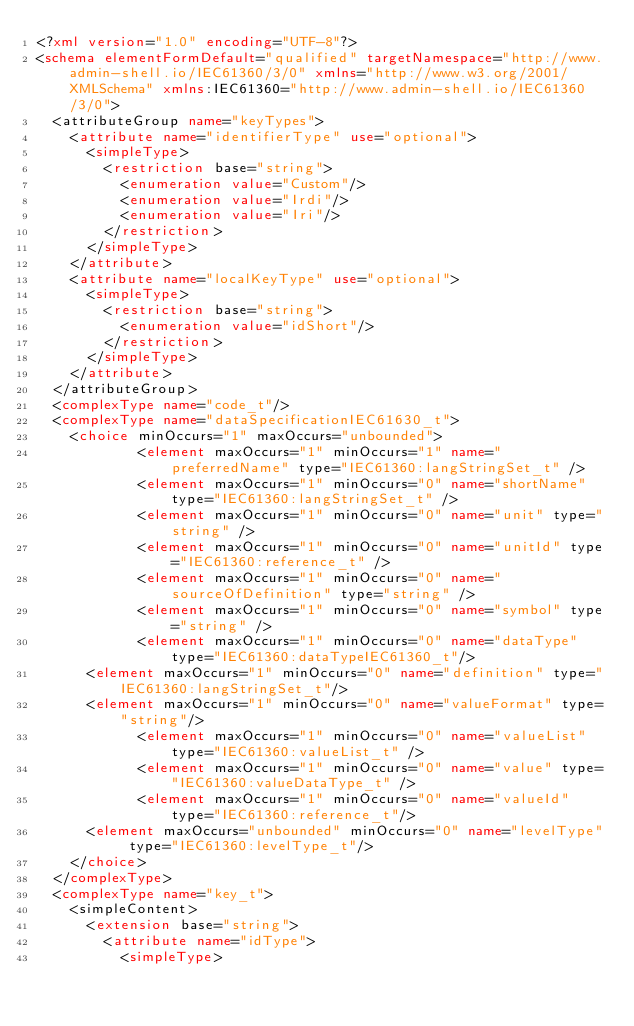Convert code to text. <code><loc_0><loc_0><loc_500><loc_500><_XML_><?xml version="1.0" encoding="UTF-8"?>
<schema elementFormDefault="qualified" targetNamespace="http://www.admin-shell.io/IEC61360/3/0" xmlns="http://www.w3.org/2001/XMLSchema" xmlns:IEC61360="http://www.admin-shell.io/IEC61360/3/0">
	<attributeGroup name="keyTypes">
		<attribute name="identifierType" use="optional">
			<simpleType>
				<restriction base="string">
					<enumeration value="Custom"/>
					<enumeration value="Irdi"/>
					<enumeration value="Iri"/>
				</restriction>
			</simpleType>
		</attribute>
		<attribute name="localKeyType" use="optional">
			<simpleType>
				<restriction base="string">
					<enumeration value="idShort"/>
				</restriction>
			</simpleType>
		</attribute>
	</attributeGroup>
	<complexType name="code_t"/>
	<complexType name="dataSpecificationIEC61630_t">
		<choice minOccurs="1" maxOccurs="unbounded">
            <element maxOccurs="1" minOccurs="1" name="preferredName" type="IEC61360:langStringSet_t" />
            <element maxOccurs="1" minOccurs="0" name="shortName" type="IEC61360:langStringSet_t" />
            <element maxOccurs="1" minOccurs="0" name="unit" type="string" />
            <element maxOccurs="1" minOccurs="0" name="unitId" type="IEC61360:reference_t" />
            <element maxOccurs="1" minOccurs="0" name="sourceOfDefinition" type="string" />
            <element maxOccurs="1" minOccurs="0" name="symbol" type="string" />
            <element maxOccurs="1" minOccurs="0" name="dataType" type="IEC61360:dataTypeIEC61360_t"/>
			<element maxOccurs="1" minOccurs="0" name="definition" type="IEC61360:langStringSet_t"/>
			<element maxOccurs="1" minOccurs="0" name="valueFormat" type="string"/>
            <element maxOccurs="1" minOccurs="0" name="valueList" type="IEC61360:valueList_t" />
            <element maxOccurs="1" minOccurs="0" name="value" type="IEC61360:valueDataType_t" />
            <element maxOccurs="1" minOccurs="0" name="valueId" type="IEC61360:reference_t"/>
			<element maxOccurs="unbounded" minOccurs="0" name="levelType" type="IEC61360:levelType_t"/>
		</choice>
	</complexType>
	<complexType name="key_t">
		<simpleContent>
			<extension base="string">
				<attribute name="idType">
					<simpleType></code> 